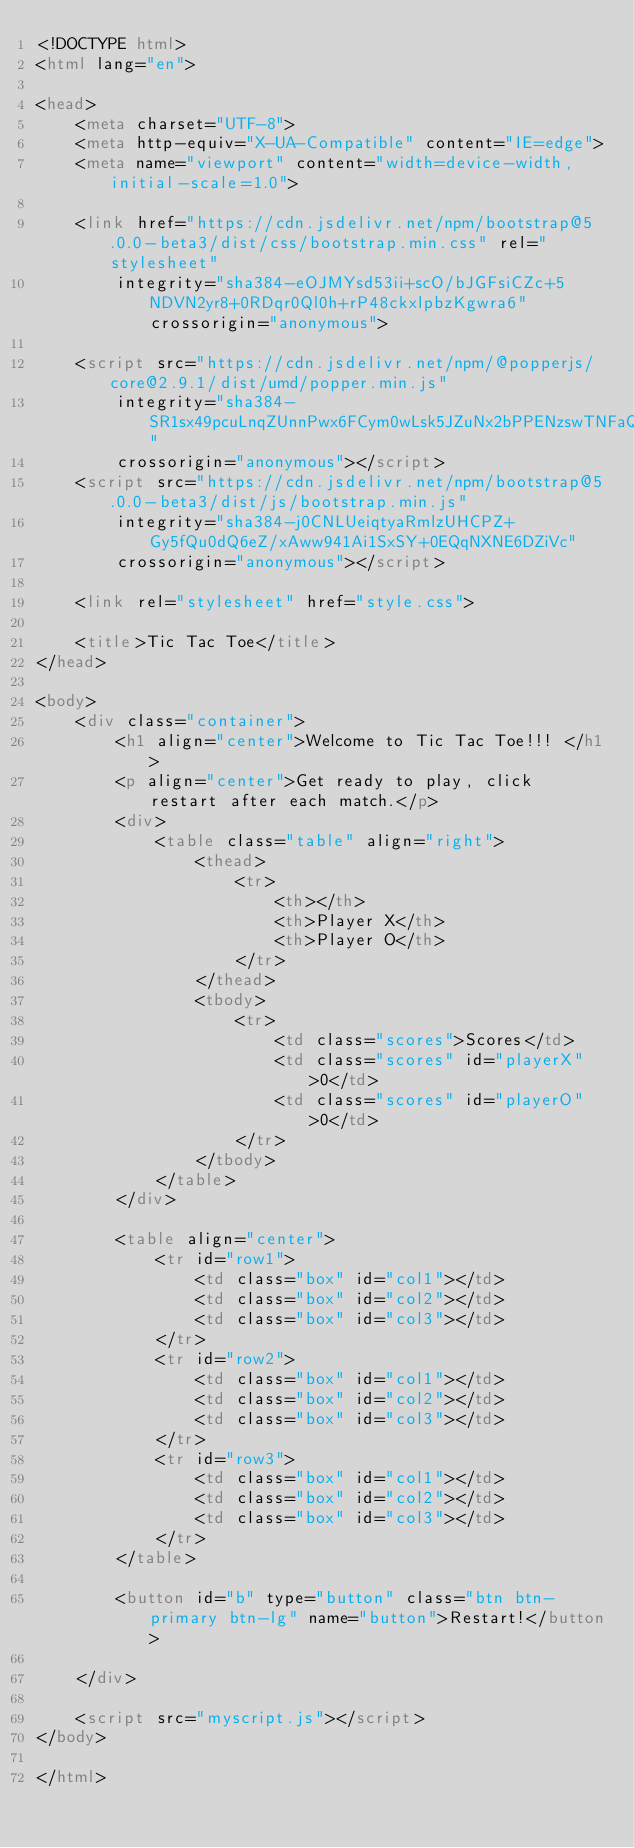<code> <loc_0><loc_0><loc_500><loc_500><_HTML_><!DOCTYPE html>
<html lang="en">

<head>
    <meta charset="UTF-8">
    <meta http-equiv="X-UA-Compatible" content="IE=edge">
    <meta name="viewport" content="width=device-width, initial-scale=1.0">

    <link href="https://cdn.jsdelivr.net/npm/bootstrap@5.0.0-beta3/dist/css/bootstrap.min.css" rel="stylesheet"
        integrity="sha384-eOJMYsd53ii+scO/bJGFsiCZc+5NDVN2yr8+0RDqr0Ql0h+rP48ckxlpbzKgwra6" crossorigin="anonymous">

    <script src="https://cdn.jsdelivr.net/npm/@popperjs/core@2.9.1/dist/umd/popper.min.js"
        integrity="sha384-SR1sx49pcuLnqZUnnPwx6FCym0wLsk5JZuNx2bPPENzswTNFaQU1RDvt3wT4gWFG"
        crossorigin="anonymous"></script>
    <script src="https://cdn.jsdelivr.net/npm/bootstrap@5.0.0-beta3/dist/js/bootstrap.min.js"
        integrity="sha384-j0CNLUeiqtyaRmlzUHCPZ+Gy5fQu0dQ6eZ/xAww941Ai1SxSY+0EQqNXNE6DZiVc"
        crossorigin="anonymous"></script>

    <link rel="stylesheet" href="style.css">

    <title>Tic Tac Toe</title>
</head>

<body>
    <div class="container">
        <h1 align="center">Welcome to Tic Tac Toe!!! </h1>
        <p align="center">Get ready to play, click restart after each match.</p>
        <div>
            <table class="table" align="right">
                <thead>
                    <tr>
                        <th></th>
                        <th>Player X</th>
                        <th>Player O</th>
                    </tr>
                </thead>
                <tbody>
                    <tr>
                        <td class="scores">Scores</td>
                        <td class="scores" id="playerX">0</td>
                        <td class="scores" id="playerO">0</td>
                    </tr>
                </tbody>
            </table>
        </div>

        <table align="center">
            <tr id="row1">
                <td class="box" id="col1"></td>
                <td class="box" id="col2"></td>
                <td class="box" id="col3"></td>
            </tr>
            <tr id="row2">
                <td class="box" id="col1"></td>
                <td class="box" id="col2"></td>
                <td class="box" id="col3"></td>
            </tr>
            <tr id="row3">
                <td class="box" id="col1"></td>
                <td class="box" id="col2"></td>
                <td class="box" id="col3"></td>
            </tr>
        </table>

        <button id="b" type="button" class="btn btn-primary btn-lg" name="button">Restart!</button>

    </div>

    <script src="myscript.js"></script>
</body>

</html></code> 